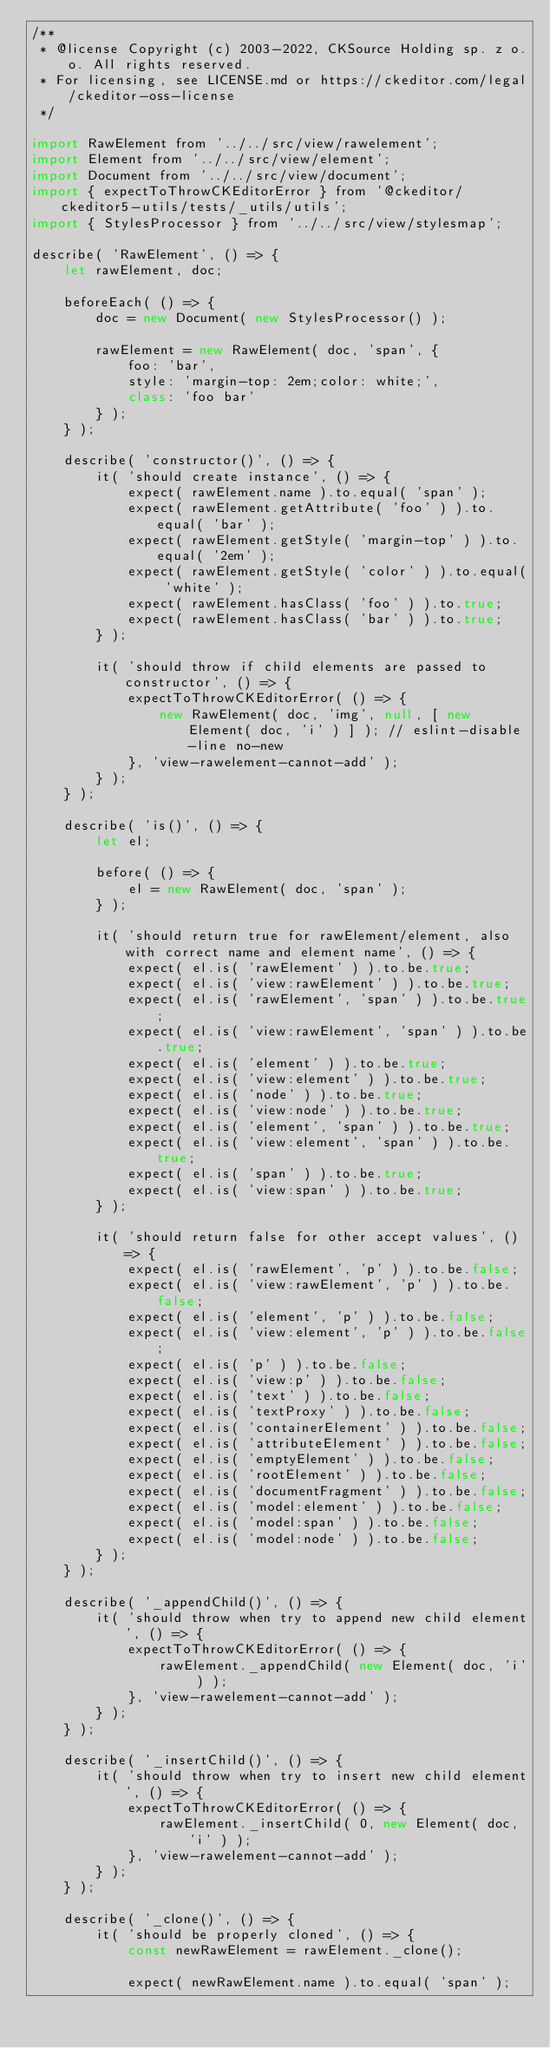<code> <loc_0><loc_0><loc_500><loc_500><_JavaScript_>/**
 * @license Copyright (c) 2003-2022, CKSource Holding sp. z o.o. All rights reserved.
 * For licensing, see LICENSE.md or https://ckeditor.com/legal/ckeditor-oss-license
 */

import RawElement from '../../src/view/rawelement';
import Element from '../../src/view/element';
import Document from '../../src/view/document';
import { expectToThrowCKEditorError } from '@ckeditor/ckeditor5-utils/tests/_utils/utils';
import { StylesProcessor } from '../../src/view/stylesmap';

describe( 'RawElement', () => {
	let rawElement, doc;

	beforeEach( () => {
		doc = new Document( new StylesProcessor() );

		rawElement = new RawElement( doc, 'span', {
			foo: 'bar',
			style: 'margin-top: 2em;color: white;',
			class: 'foo bar'
		} );
	} );

	describe( 'constructor()', () => {
		it( 'should create instance', () => {
			expect( rawElement.name ).to.equal( 'span' );
			expect( rawElement.getAttribute( 'foo' ) ).to.equal( 'bar' );
			expect( rawElement.getStyle( 'margin-top' ) ).to.equal( '2em' );
			expect( rawElement.getStyle( 'color' ) ).to.equal( 'white' );
			expect( rawElement.hasClass( 'foo' ) ).to.true;
			expect( rawElement.hasClass( 'bar' ) ).to.true;
		} );

		it( 'should throw if child elements are passed to constructor', () => {
			expectToThrowCKEditorError( () => {
				new RawElement( doc, 'img', null, [ new Element( doc, 'i' ) ] ); // eslint-disable-line no-new
			}, 'view-rawelement-cannot-add' );
		} );
	} );

	describe( 'is()', () => {
		let el;

		before( () => {
			el = new RawElement( doc, 'span' );
		} );

		it( 'should return true for rawElement/element, also with correct name and element name', () => {
			expect( el.is( 'rawElement' ) ).to.be.true;
			expect( el.is( 'view:rawElement' ) ).to.be.true;
			expect( el.is( 'rawElement', 'span' ) ).to.be.true;
			expect( el.is( 'view:rawElement', 'span' ) ).to.be.true;
			expect( el.is( 'element' ) ).to.be.true;
			expect( el.is( 'view:element' ) ).to.be.true;
			expect( el.is( 'node' ) ).to.be.true;
			expect( el.is( 'view:node' ) ).to.be.true;
			expect( el.is( 'element', 'span' ) ).to.be.true;
			expect( el.is( 'view:element', 'span' ) ).to.be.true;
			expect( el.is( 'span' ) ).to.be.true;
			expect( el.is( 'view:span' ) ).to.be.true;
		} );

		it( 'should return false for other accept values', () => {
			expect( el.is( 'rawElement', 'p' ) ).to.be.false;
			expect( el.is( 'view:rawElement', 'p' ) ).to.be.false;
			expect( el.is( 'element', 'p' ) ).to.be.false;
			expect( el.is( 'view:element', 'p' ) ).to.be.false;
			expect( el.is( 'p' ) ).to.be.false;
			expect( el.is( 'view:p' ) ).to.be.false;
			expect( el.is( 'text' ) ).to.be.false;
			expect( el.is( 'textProxy' ) ).to.be.false;
			expect( el.is( 'containerElement' ) ).to.be.false;
			expect( el.is( 'attributeElement' ) ).to.be.false;
			expect( el.is( 'emptyElement' ) ).to.be.false;
			expect( el.is( 'rootElement' ) ).to.be.false;
			expect( el.is( 'documentFragment' ) ).to.be.false;
			expect( el.is( 'model:element' ) ).to.be.false;
			expect( el.is( 'model:span' ) ).to.be.false;
			expect( el.is( 'model:node' ) ).to.be.false;
		} );
	} );

	describe( '_appendChild()', () => {
		it( 'should throw when try to append new child element', () => {
			expectToThrowCKEditorError( () => {
				rawElement._appendChild( new Element( doc, 'i' ) );
			}, 'view-rawelement-cannot-add' );
		} );
	} );

	describe( '_insertChild()', () => {
		it( 'should throw when try to insert new child element', () => {
			expectToThrowCKEditorError( () => {
				rawElement._insertChild( 0, new Element( doc, 'i' ) );
			}, 'view-rawelement-cannot-add' );
		} );
	} );

	describe( '_clone()', () => {
		it( 'should be properly cloned', () => {
			const newRawElement = rawElement._clone();

			expect( newRawElement.name ).to.equal( 'span' );</code> 